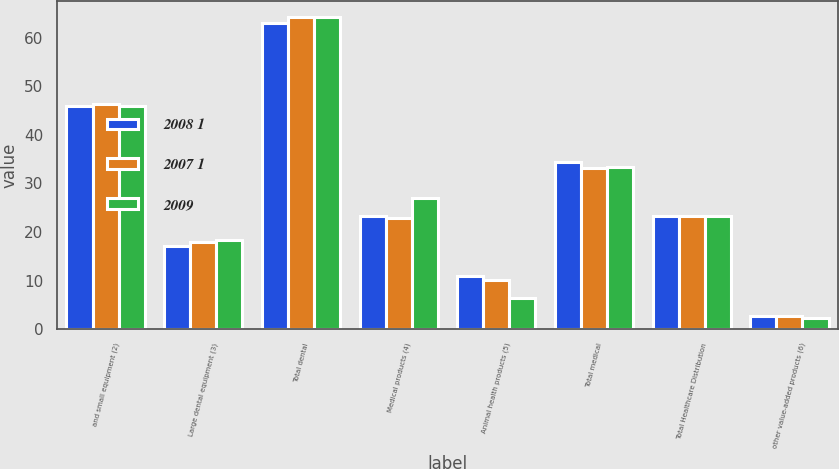<chart> <loc_0><loc_0><loc_500><loc_500><stacked_bar_chart><ecel><fcel>and small equipment (2)<fcel>Large dental equipment (3)<fcel>Total dental<fcel>Medical products (4)<fcel>Animal health products (5)<fcel>Total medical<fcel>Total Healthcare Distribution<fcel>other value-added products (6)<nl><fcel>2008 1<fcel>45.9<fcel>17.1<fcel>63<fcel>23.4<fcel>11<fcel>34.4<fcel>23.4<fcel>2.6<nl><fcel>2007 1<fcel>46.4<fcel>17.9<fcel>64.3<fcel>22.9<fcel>10.2<fcel>33.1<fcel>23.4<fcel>2.6<nl><fcel>2009<fcel>46<fcel>18.3<fcel>64.3<fcel>27<fcel>6.5<fcel>33.5<fcel>23.4<fcel>2.2<nl></chart> 